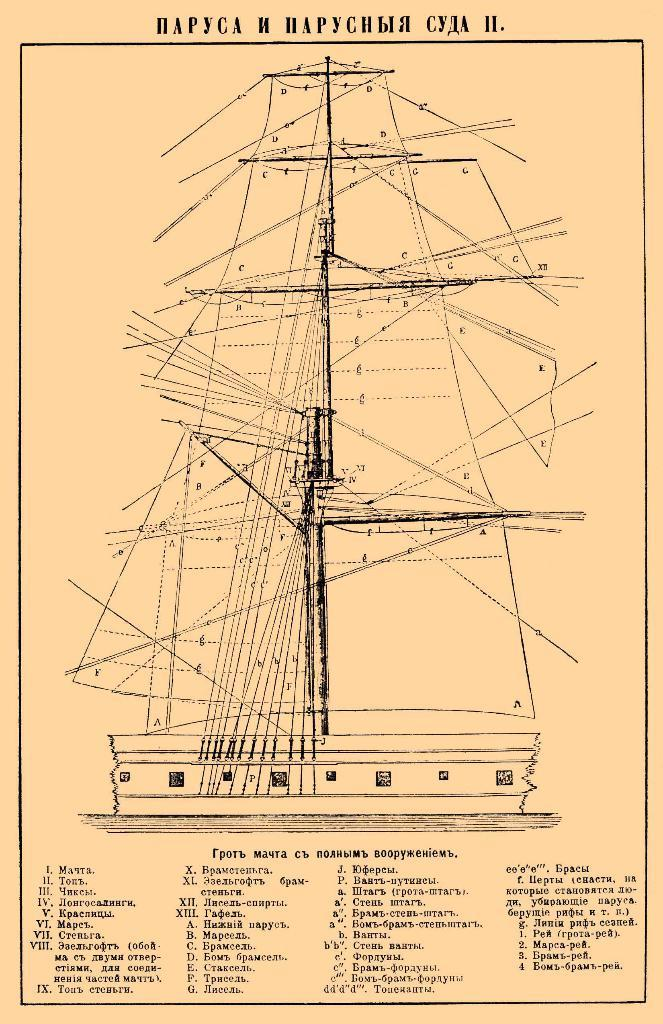What is the main subject of the poster in the image? The poster contains a sketch of a ship. Is there any text on the poster? Yes, there is text written at the bottom of the poster. How many sticks are being held by the worm in the image? There is no worm or sticks present in the image. 